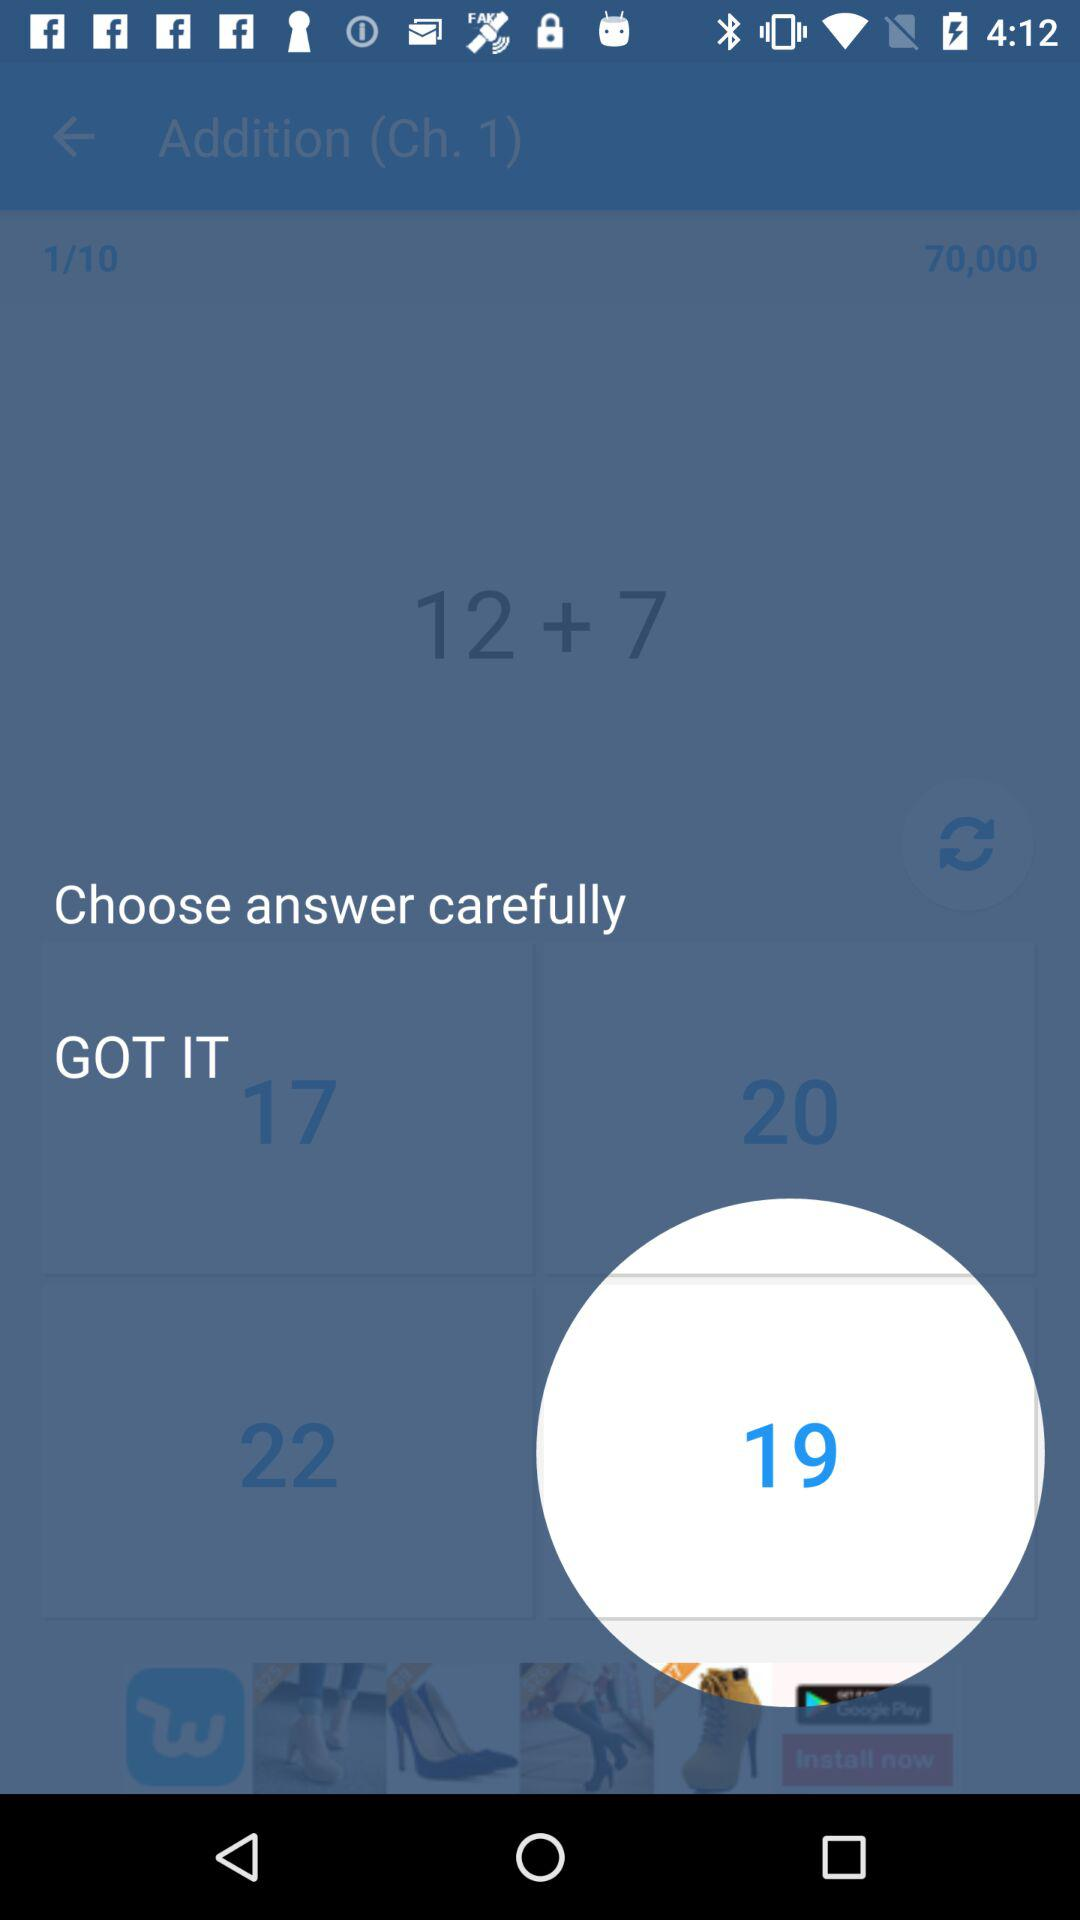Which option is selected? The selected option is "19". 